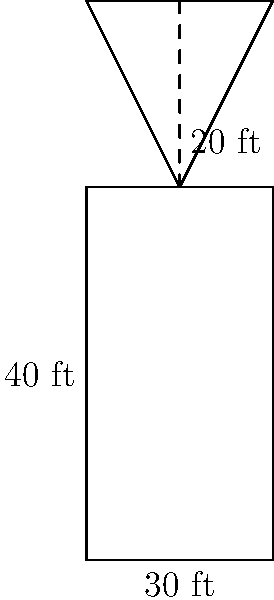The Portland Head Light, Maine's oldest lighthouse, can be approximated as a cylinder with a conical top. If the cylindrical part has a height of 40 feet and a diameter of 30 feet, and the conical top has a height of 20 feet, what is the total surface area of the lighthouse (excluding the base)? Round your answer to the nearest square foot. Let's break this down step-by-step:

1) First, we need to calculate the surface area of the cylinder (excluding top and bottom):
   Cylinder surface area = $\pi d h$ where $d$ is diameter and $h$ is height
   $SA_{cylinder} = \pi \cdot 30 \cdot 40 = 3770.35$ sq ft

2) Next, we need the area of the circular top of the cylinder:
   Circle area = $\pi r^2$ where $r$ is radius
   $A_{circle} = \pi \cdot (15)^2 = 706.86$ sq ft

3) For the cone, we need its slant height. We can find this using the Pythagorean theorem:
   $s^2 = r^2 + h^2$ where $s$ is slant height, $r$ is radius, and $h$ is height
   $s^2 = 15^2 + 20^2 = 625$
   $s = \sqrt{625} = 25$ ft

4) Now we can calculate the surface area of the cone:
   Cone surface area = $\pi r s$ where $r$ is radius and $s$ is slant height
   $SA_{cone} = \pi \cdot 15 \cdot 25 = 1178.10$ sq ft

5) The total surface area is the sum of these parts:
   $SA_{total} = SA_{cylinder} + SA_{cone} = 3770.35 + 1178.10 = 4948.45$ sq ft

6) Rounding to the nearest square foot: 4948 sq ft
Answer: 4948 sq ft 